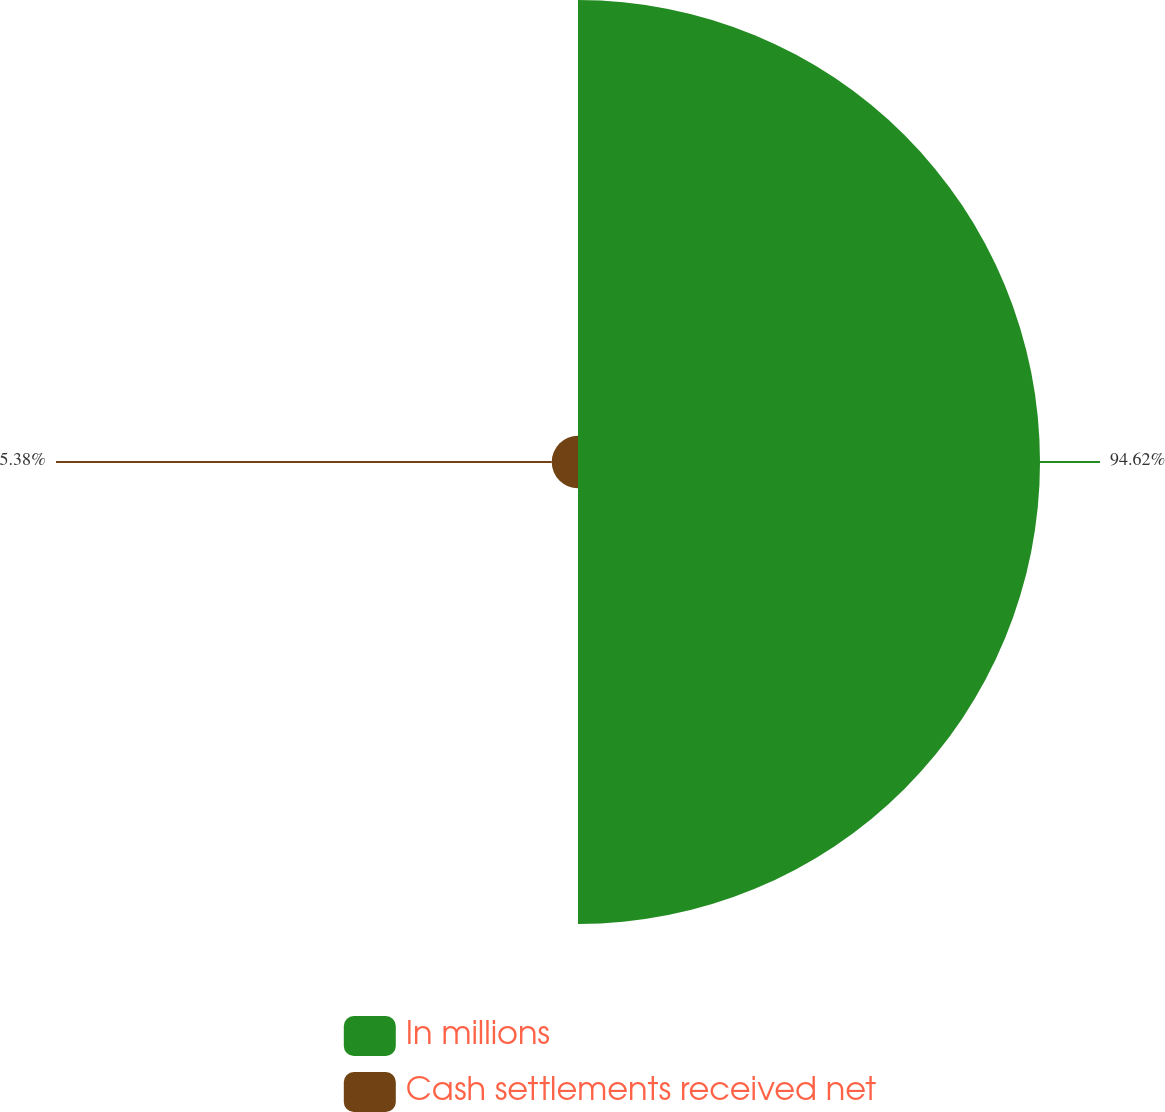Convert chart to OTSL. <chart><loc_0><loc_0><loc_500><loc_500><pie_chart><fcel>In millions<fcel>Cash settlements received net<nl><fcel>94.62%<fcel>5.38%<nl></chart> 